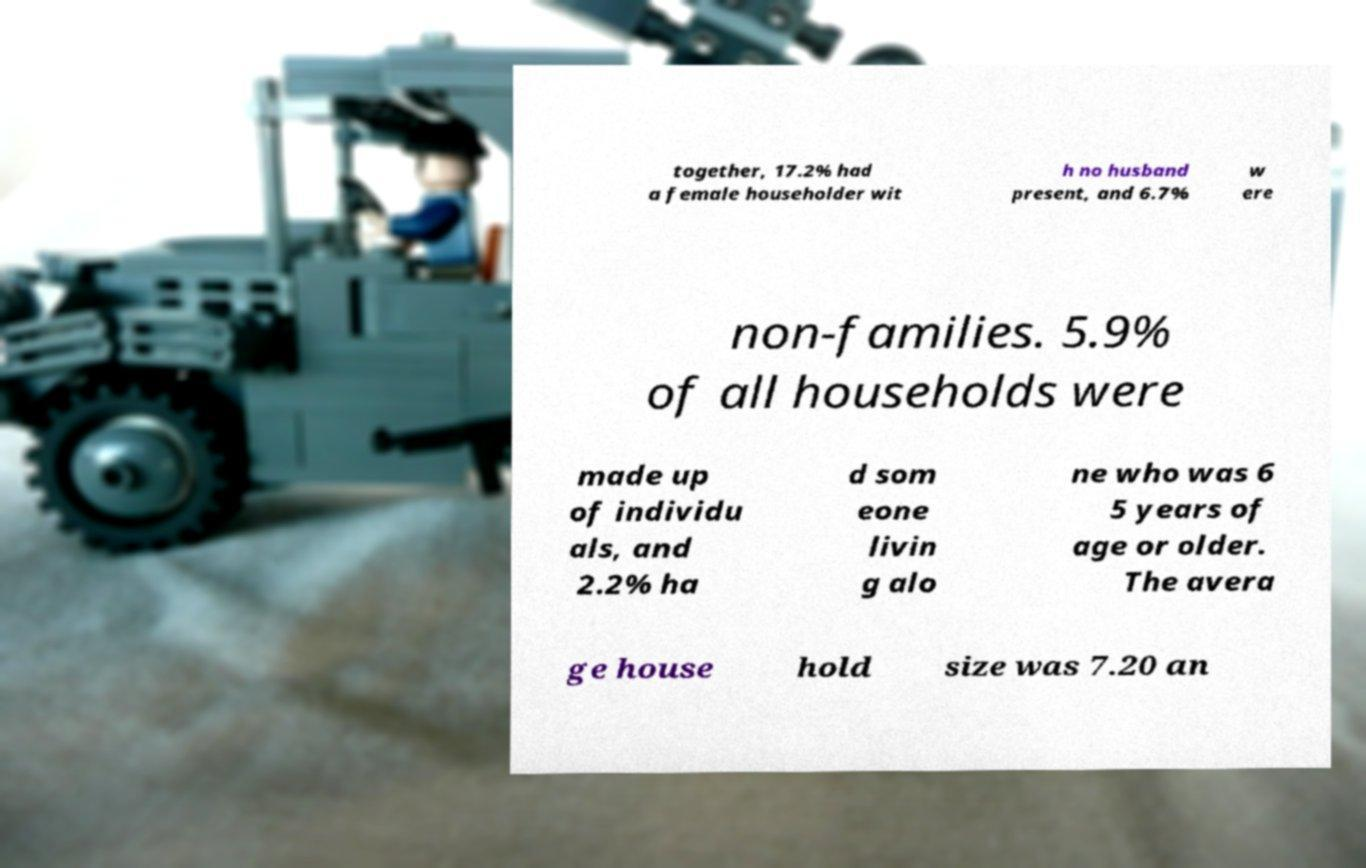Please identify and transcribe the text found in this image. together, 17.2% had a female householder wit h no husband present, and 6.7% w ere non-families. 5.9% of all households were made up of individu als, and 2.2% ha d som eone livin g alo ne who was 6 5 years of age or older. The avera ge house hold size was 7.20 an 